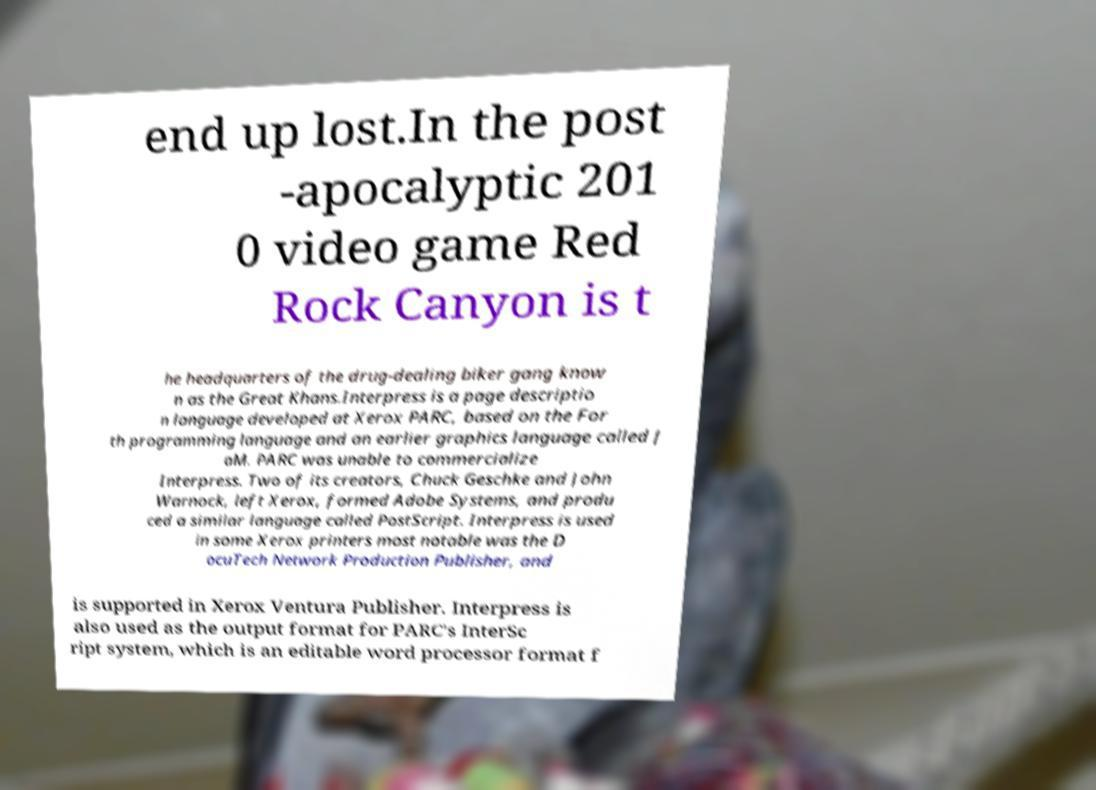For documentation purposes, I need the text within this image transcribed. Could you provide that? end up lost.In the post -apocalyptic 201 0 video game Red Rock Canyon is t he headquarters of the drug-dealing biker gang know n as the Great Khans.Interpress is a page descriptio n language developed at Xerox PARC, based on the For th programming language and an earlier graphics language called J aM. PARC was unable to commercialize Interpress. Two of its creators, Chuck Geschke and John Warnock, left Xerox, formed Adobe Systems, and produ ced a similar language called PostScript. Interpress is used in some Xerox printers most notable was the D ocuTech Network Production Publisher, and is supported in Xerox Ventura Publisher. Interpress is also used as the output format for PARC's InterSc ript system, which is an editable word processor format f 